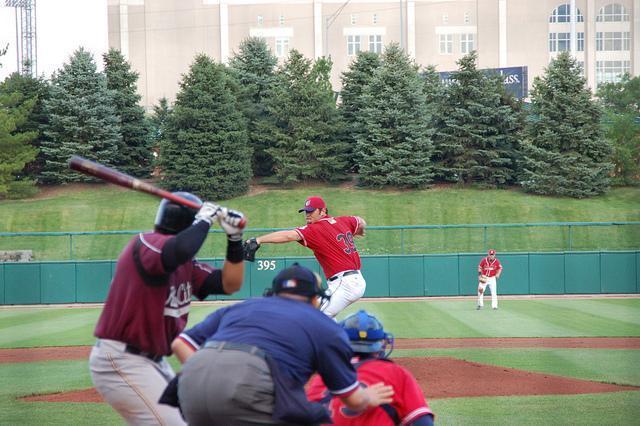How many people can be seen?
Give a very brief answer. 4. How many birds are flying in the picture?
Give a very brief answer. 0. 